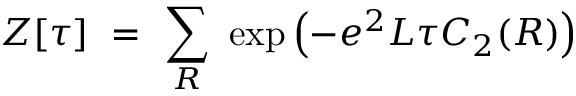Convert formula to latex. <formula><loc_0><loc_0><loc_500><loc_500>Z [ \tau ] = \sum _ { R } \exp \left ( - e ^ { 2 } L \tau C _ { 2 } ( R ) \right )</formula> 